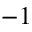<formula> <loc_0><loc_0><loc_500><loc_500>- 1</formula> 